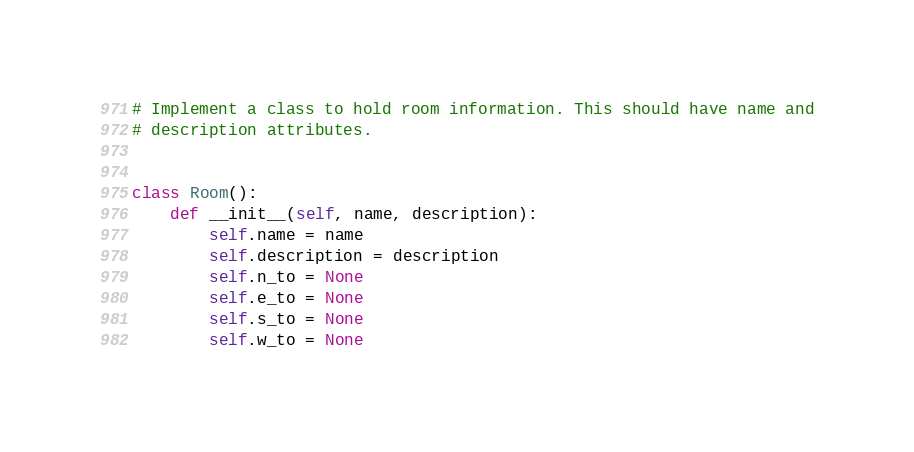Convert code to text. <code><loc_0><loc_0><loc_500><loc_500><_Python_># Implement a class to hold room information. This should have name and
# description attributes.


class Room():
    def __init__(self, name, description):
        self.name = name
        self.description = description
        self.n_to = None
        self.e_to = None
        self.s_to = None
        self.w_to = None</code> 